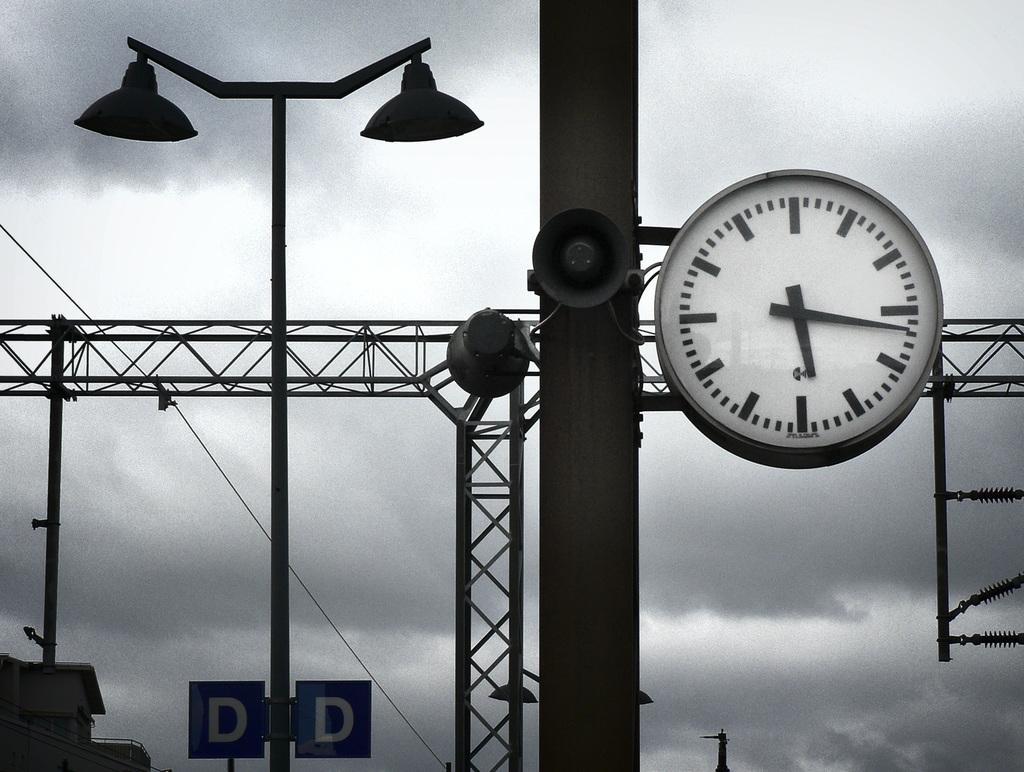In one or two sentences, can you explain what this image depicts? In this image, we can see a pole contains speaker and clock. There is a metal frame in the middle of the image. There is an another pole contains lights. In the background of the image, there is a sky. 